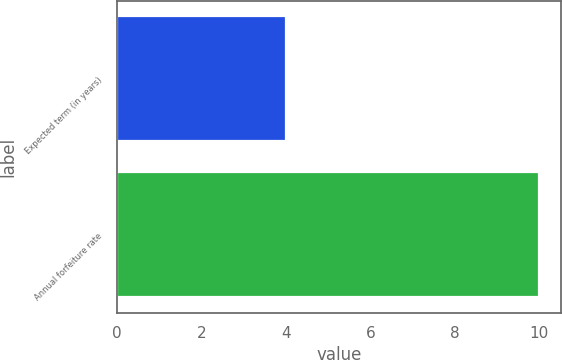Convert chart. <chart><loc_0><loc_0><loc_500><loc_500><bar_chart><fcel>Expected term (in years)<fcel>Annual forfeiture rate<nl><fcel>4<fcel>10<nl></chart> 